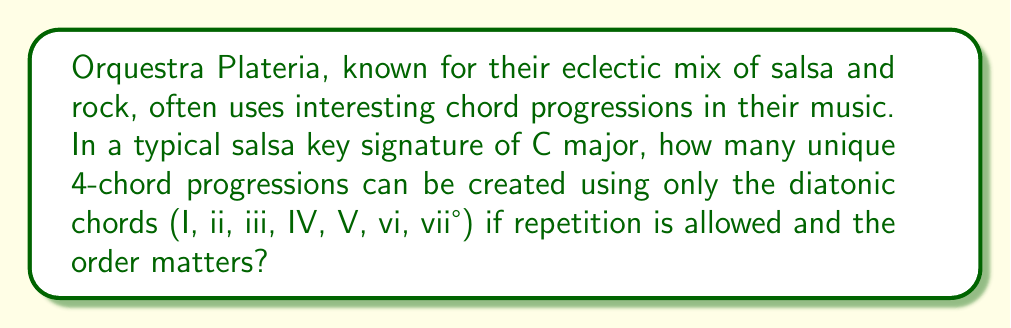Can you answer this question? To solve this problem, we need to follow these steps:

1) First, let's identify the diatonic chords in C major:
   I   = C
   ii  = Dm
   iii = Em
   IV  = F
   V   = G
   vi  = Am
   vii°= B°

2) We are creating a 4-chord progression, and we can use any of these 7 chords in any position. This is a case of selecting with replacement (as repetition is allowed) and the order matters.

3) In mathematical terms, this is equivalent to finding the number of ways to fill 4 positions, where each position has 7 possible choices.

4) This scenario can be represented by the multiplication principle. For each of the 4 positions in the progression, we have 7 choices. Therefore, the total number of possible progressions is:

   $$ 7 \times 7 \times 7 \times 7 = 7^4 $$

5) To calculate $7^4$:
   $$ 7^4 = 7 \times 7 \times 7 \times 7 = 2401 $$

Therefore, there are 2401 possible unique 4-chord progressions in C major using only the diatonic chords.
Answer: $2401$ 